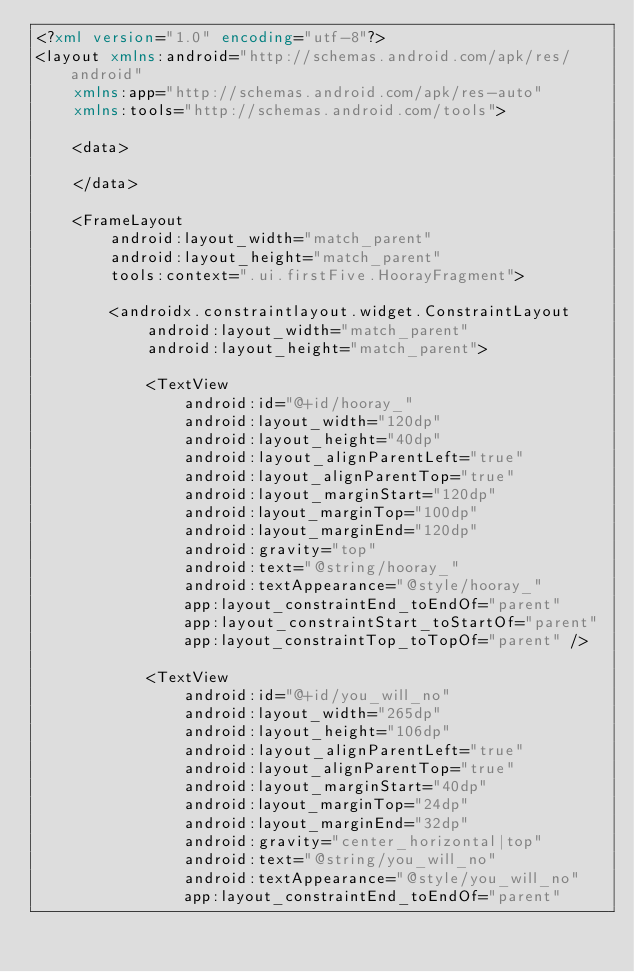<code> <loc_0><loc_0><loc_500><loc_500><_XML_><?xml version="1.0" encoding="utf-8"?>
<layout xmlns:android="http://schemas.android.com/apk/res/android"
    xmlns:app="http://schemas.android.com/apk/res-auto"
    xmlns:tools="http://schemas.android.com/tools">

    <data>

    </data>

    <FrameLayout
        android:layout_width="match_parent"
        android:layout_height="match_parent"
        tools:context=".ui.firstFive.HoorayFragment">

        <androidx.constraintlayout.widget.ConstraintLayout
            android:layout_width="match_parent"
            android:layout_height="match_parent">

            <TextView
                android:id="@+id/hooray_"
                android:layout_width="120dp"
                android:layout_height="40dp"
                android:layout_alignParentLeft="true"
                android:layout_alignParentTop="true"
                android:layout_marginStart="120dp"
                android:layout_marginTop="100dp"
                android:layout_marginEnd="120dp"
                android:gravity="top"
                android:text="@string/hooray_"
                android:textAppearance="@style/hooray_"
                app:layout_constraintEnd_toEndOf="parent"
                app:layout_constraintStart_toStartOf="parent"
                app:layout_constraintTop_toTopOf="parent" />

            <TextView
                android:id="@+id/you_will_no"
                android:layout_width="265dp"
                android:layout_height="106dp"
                android:layout_alignParentLeft="true"
                android:layout_alignParentTop="true"
                android:layout_marginStart="40dp"
                android:layout_marginTop="24dp"
                android:layout_marginEnd="32dp"
                android:gravity="center_horizontal|top"
                android:text="@string/you_will_no"
                android:textAppearance="@style/you_will_no"
                app:layout_constraintEnd_toEndOf="parent"</code> 